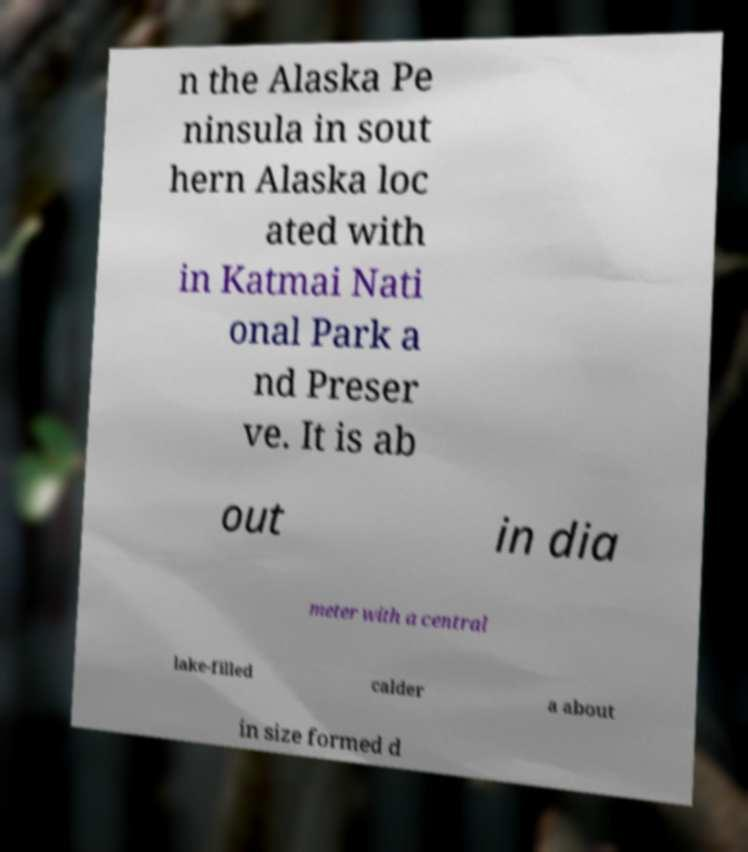Can you accurately transcribe the text from the provided image for me? n the Alaska Pe ninsula in sout hern Alaska loc ated with in Katmai Nati onal Park a nd Preser ve. It is ab out in dia meter with a central lake-filled calder a about in size formed d 